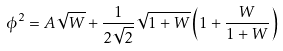<formula> <loc_0><loc_0><loc_500><loc_500>\phi ^ { 2 } = A \sqrt { W } + \frac { 1 } { 2 \sqrt { 2 } } \sqrt { 1 + W } \left ( 1 + \frac { W } { 1 + W } \right )</formula> 